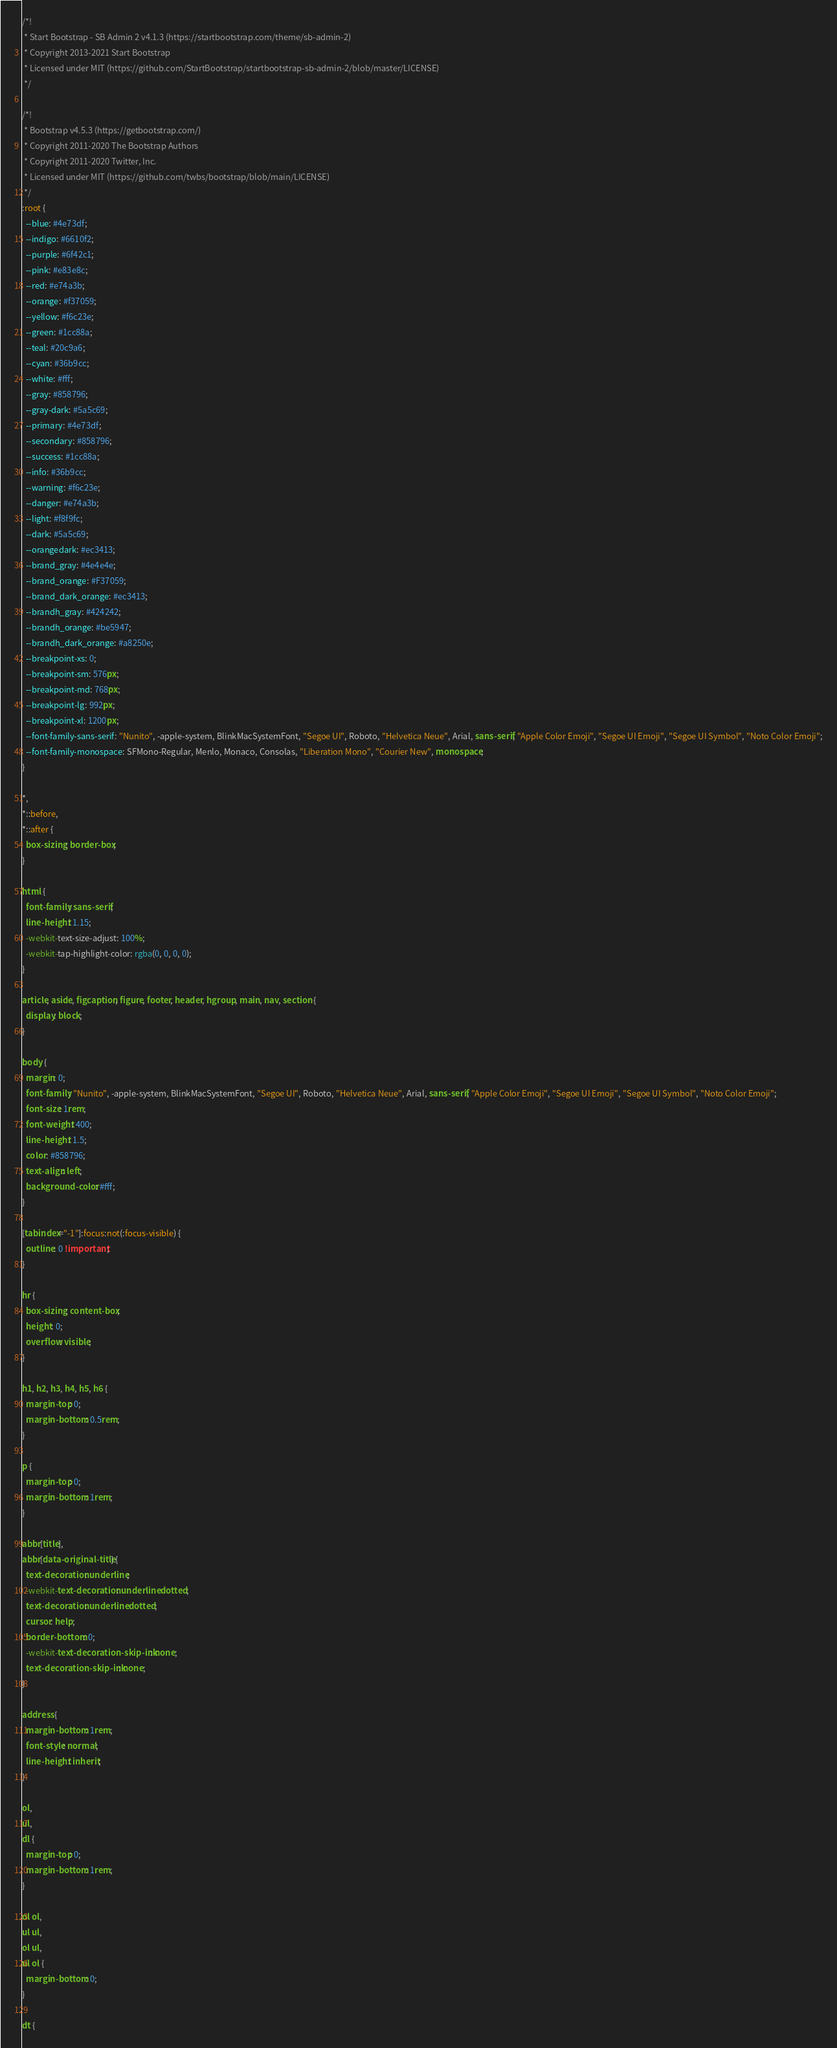<code> <loc_0><loc_0><loc_500><loc_500><_CSS_>/*!
 * Start Bootstrap - SB Admin 2 v4.1.3 (https://startbootstrap.com/theme/sb-admin-2)
 * Copyright 2013-2021 Start Bootstrap
 * Licensed under MIT (https://github.com/StartBootstrap/startbootstrap-sb-admin-2/blob/master/LICENSE)
 */

/*!
 * Bootstrap v4.5.3 (https://getbootstrap.com/)
 * Copyright 2011-2020 The Bootstrap Authors
 * Copyright 2011-2020 Twitter, Inc.
 * Licensed under MIT (https://github.com/twbs/bootstrap/blob/main/LICENSE)
 */
:root {
  --blue: #4e73df;
  --indigo: #6610f2;
  --purple: #6f42c1;
  --pink: #e83e8c;
  --red: #e74a3b;
  --orange: #f37059;
  --yellow: #f6c23e;
  --green: #1cc88a;
  --teal: #20c9a6;
  --cyan: #36b9cc;
  --white: #fff;
  --gray: #858796;
  --gray-dark: #5a5c69;
  --primary: #4e73df;
  --secondary: #858796;
  --success: #1cc88a;
  --info: #36b9cc;
  --warning: #f6c23e;
  --danger: #e74a3b;
  --light: #f8f9fc;
  --dark: #5a5c69;
  --orangedark: #ec3413;
  --brand_gray: #4e4e4e;
  --brand_orange: #F37059;
  --brand_dark_orange: #ec3413;
  --brandh_gray: #424242;
  --brandh_orange: #be5947;
  --brandh_dark_orange: #a8250e;
  --breakpoint-xs: 0;
  --breakpoint-sm: 576px;
  --breakpoint-md: 768px;
  --breakpoint-lg: 992px;
  --breakpoint-xl: 1200px;
  --font-family-sans-serif: "Nunito", -apple-system, BlinkMacSystemFont, "Segoe UI", Roboto, "Helvetica Neue", Arial, sans-serif, "Apple Color Emoji", "Segoe UI Emoji", "Segoe UI Symbol", "Noto Color Emoji";
  --font-family-monospace: SFMono-Regular, Menlo, Monaco, Consolas, "Liberation Mono", "Courier New", monospace;
}

*,
*::before,
*::after {
  box-sizing: border-box;
}

html {
  font-family: sans-serif;
  line-height: 1.15;
  -webkit-text-size-adjust: 100%;
  -webkit-tap-highlight-color: rgba(0, 0, 0, 0);
}

article, aside, figcaption, figure, footer, header, hgroup, main, nav, section {
  display: block;
}

body {
  margin: 0;
  font-family: "Nunito", -apple-system, BlinkMacSystemFont, "Segoe UI", Roboto, "Helvetica Neue", Arial, sans-serif, "Apple Color Emoji", "Segoe UI Emoji", "Segoe UI Symbol", "Noto Color Emoji";
  font-size: 1rem;
  font-weight: 400;
  line-height: 1.5;
  color: #858796;
  text-align: left;
  background-color: #fff;
}

[tabindex="-1"]:focus:not(:focus-visible) {
  outline: 0 !important;
}

hr {
  box-sizing: content-box;
  height: 0;
  overflow: visible;
}

h1, h2, h3, h4, h5, h6 {
  margin-top: 0;
  margin-bottom: 0.5rem;
}

p {
  margin-top: 0;
  margin-bottom: 1rem;
}

abbr[title],
abbr[data-original-title] {
  text-decoration: underline;
  -webkit-text-decoration: underline dotted;
  text-decoration: underline dotted;
  cursor: help;
  border-bottom: 0;
  -webkit-text-decoration-skip-ink: none;
  text-decoration-skip-ink: none;
}

address {
  margin-bottom: 1rem;
  font-style: normal;
  line-height: inherit;
}

ol,
ul,
dl {
  margin-top: 0;
  margin-bottom: 1rem;
}

ol ol,
ul ul,
ol ul,
ul ol {
  margin-bottom: 0;
}

dt {</code> 